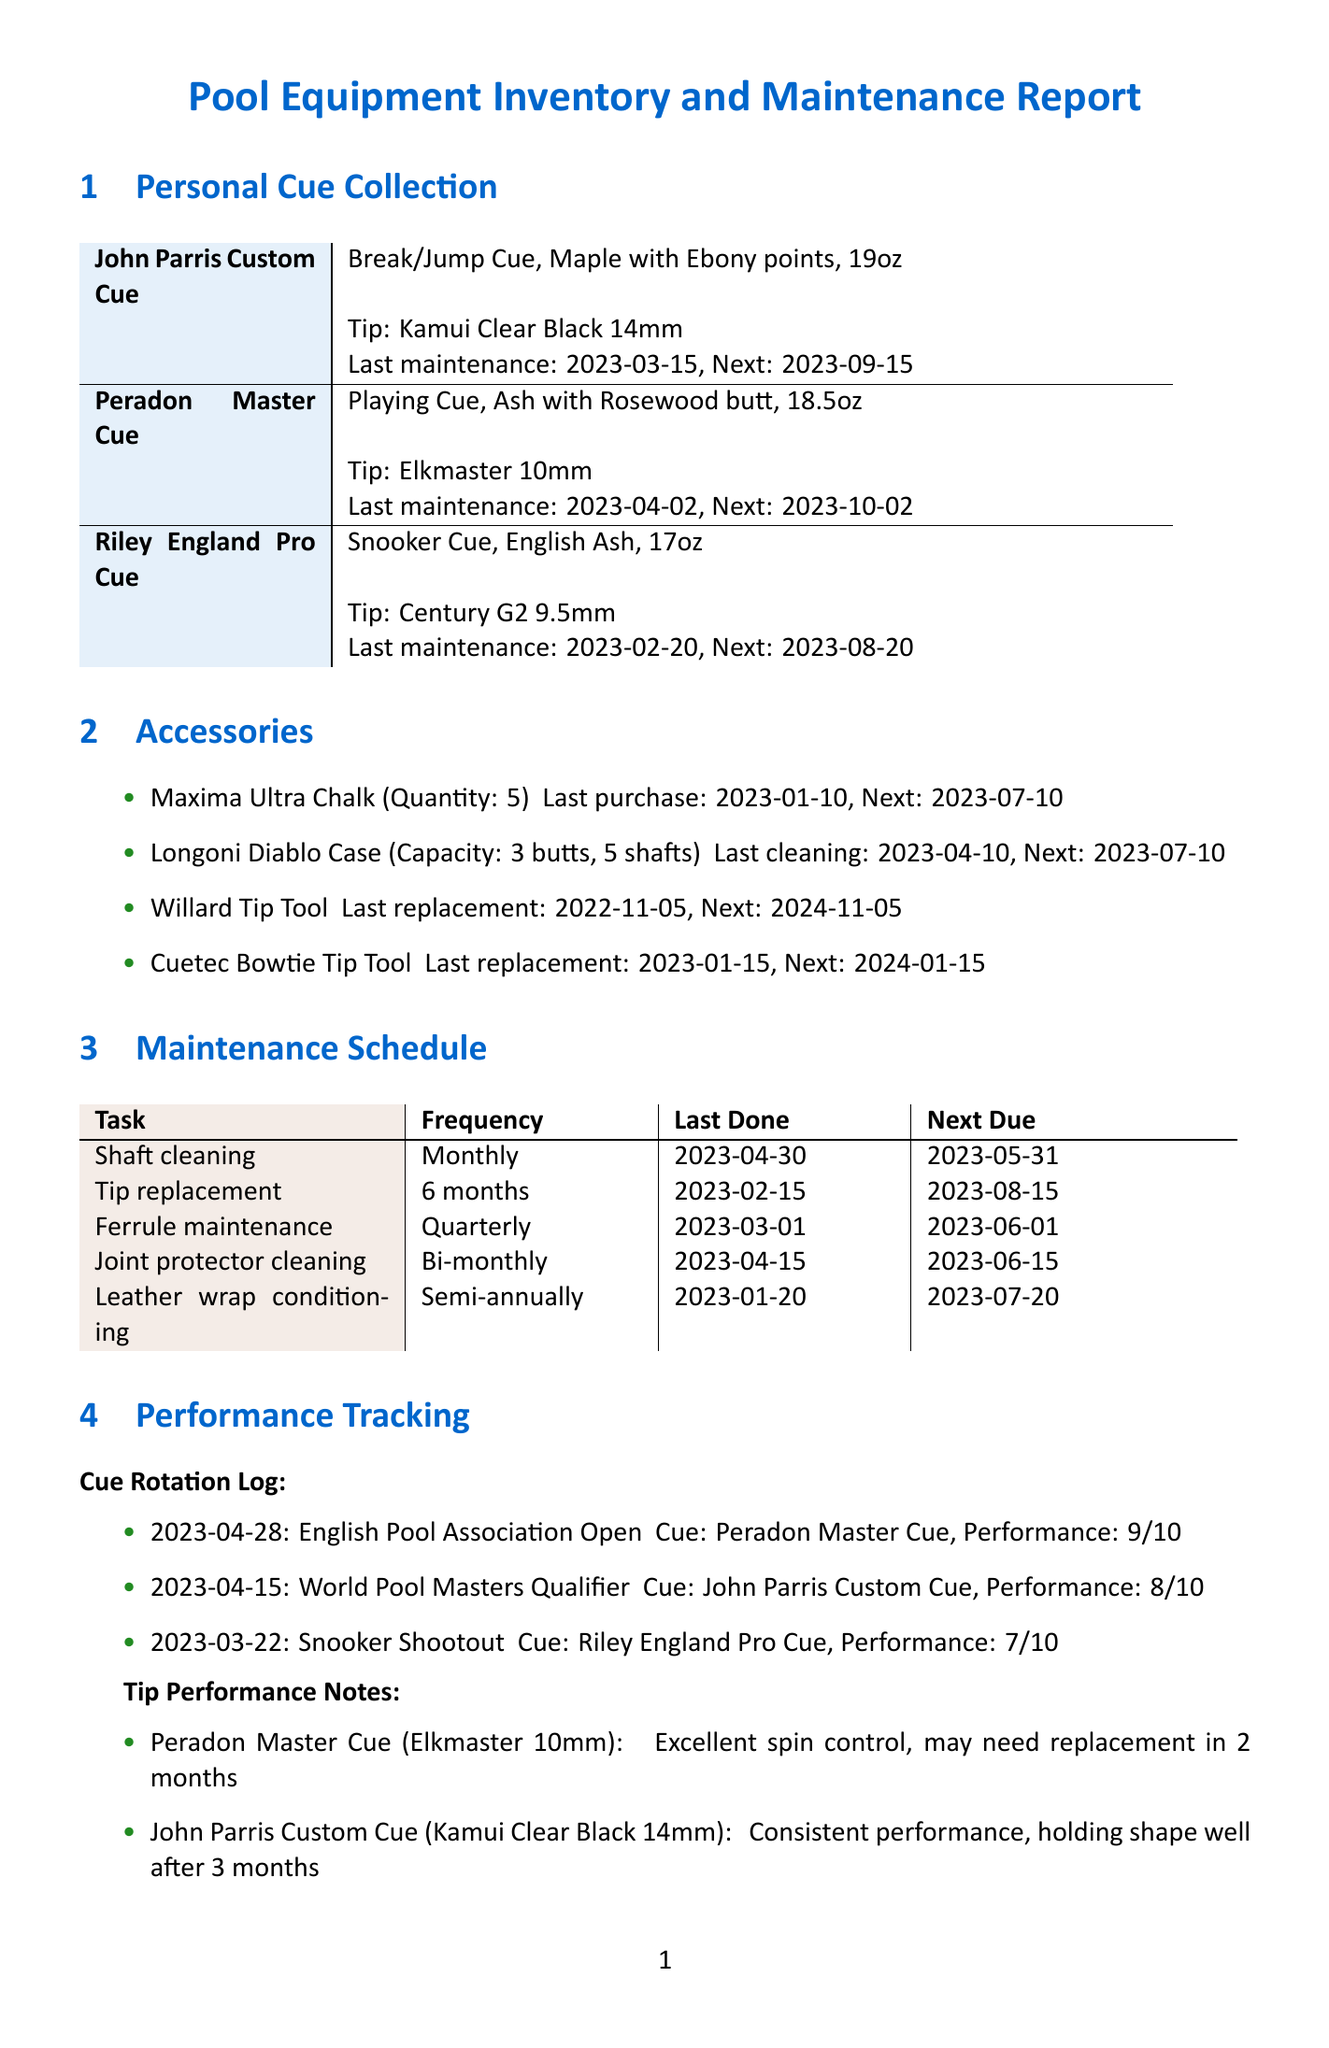What type is the John Parris Custom Cue? The cue type is specified in the document as "Break/Jump Cue".
Answer: Break/Jump Cue What material is used for the Peradon Master Cue? The material for the Peradon Master Cue is mentioned as "Ash with Rosewood butt".
Answer: Ash with Rosewood butt When is the next maintenance for the Riley England Pro Cue? The document states the next maintenance date for the Riley England Pro Cue is "2023-08-20".
Answer: 2023-08-20 How often should the leather wrap be conditioned? The frequency for leather wrap conditioning is described as "Semi-annually".
Answer: Semi-annually What is the weight of the John Parris Custom Cue? The weight of the cue is provided in the document as "19oz".
Answer: 19oz Which cue has the highest performance rating logged? The highest performance rating from the rotation log is for the Peradon Master Cue with a rating of 9.
Answer: Peradon Master Cue How many tips are in the Maxima Ultra Chalk stock? The document notes the quantity of Maxima Ultra Chalk is "5".
Answer: 5 What task needs to be performed next on May 31, 2023? The next due maintenance task on that date is specified as "Shaft cleaning and polishing".
Answer: Shaft cleaning and polishing What was the last replacement date for the Cuetec Bowtie Tip Tool? The last replacement date for the Cuetec Bowtie Tip Tool is mentioned as "2023-01-15".
Answer: 2023-01-15 